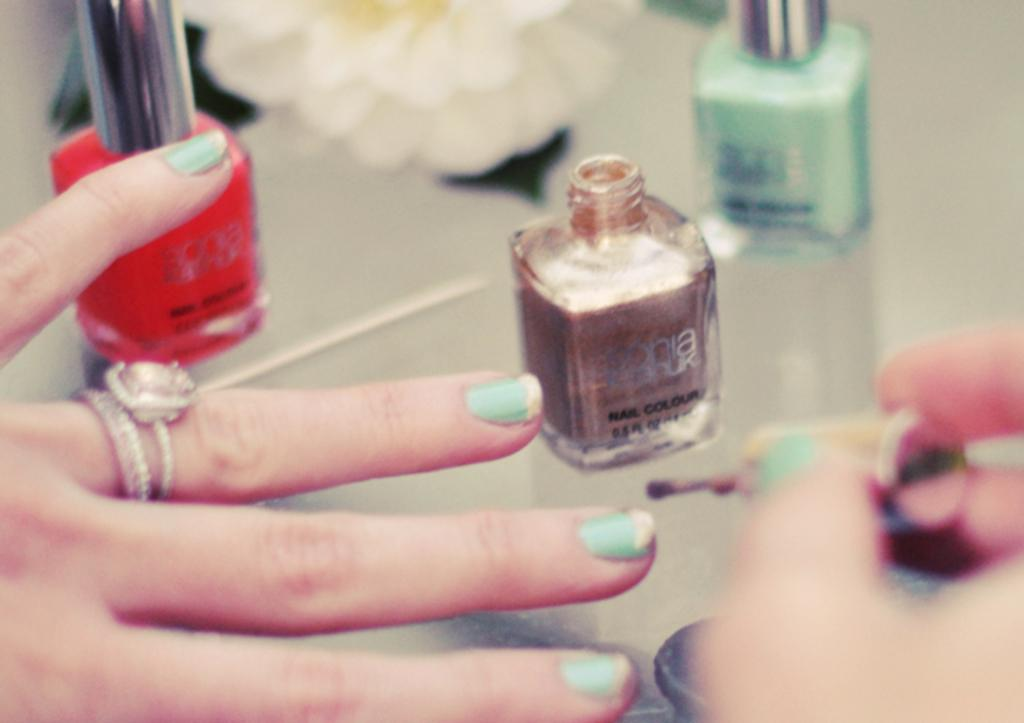Provide a one-sentence caption for the provided image. A woman applies Sonia Kashuk nail color to her fingernails. 